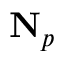Convert formula to latex. <formula><loc_0><loc_0><loc_500><loc_500>N _ { p }</formula> 